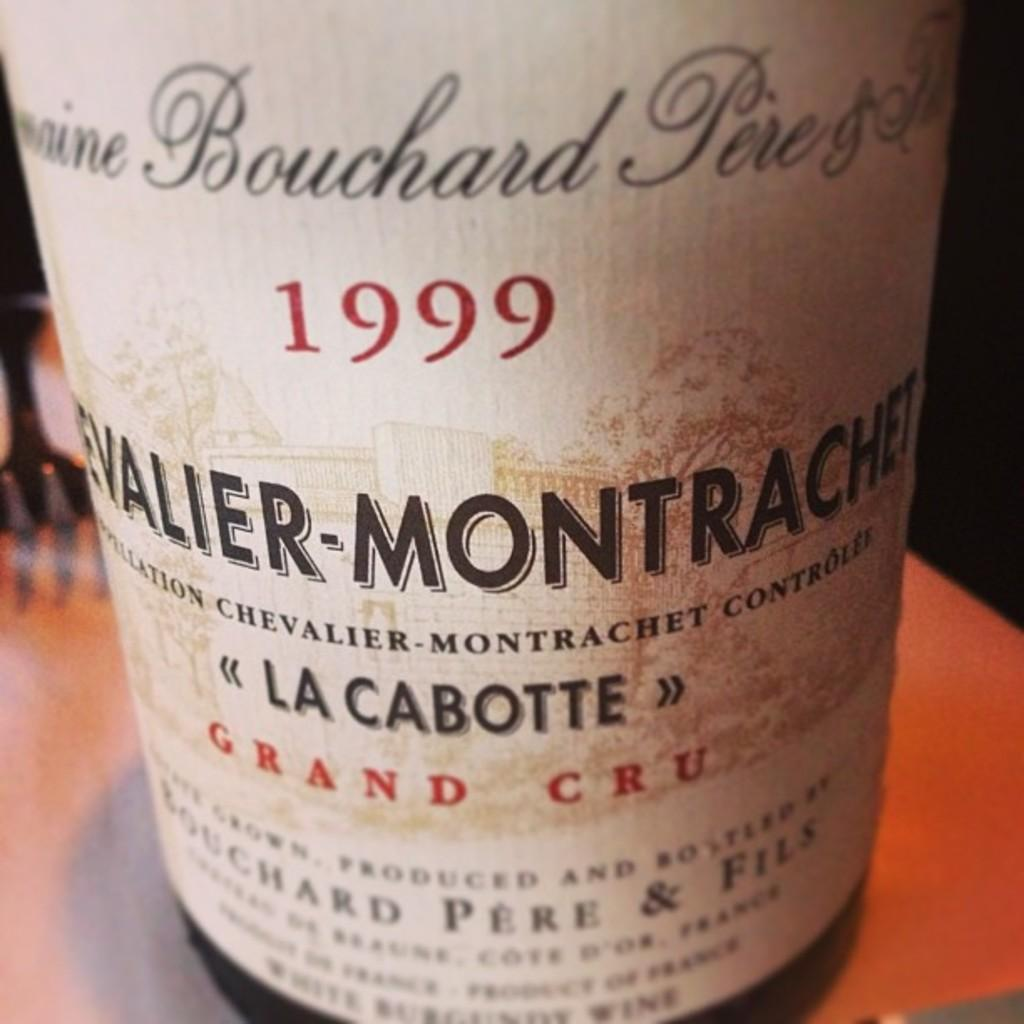<image>
Create a compact narrative representing the image presented. A bottle of grand cru from 1999 has a drawing of a building on the label. 